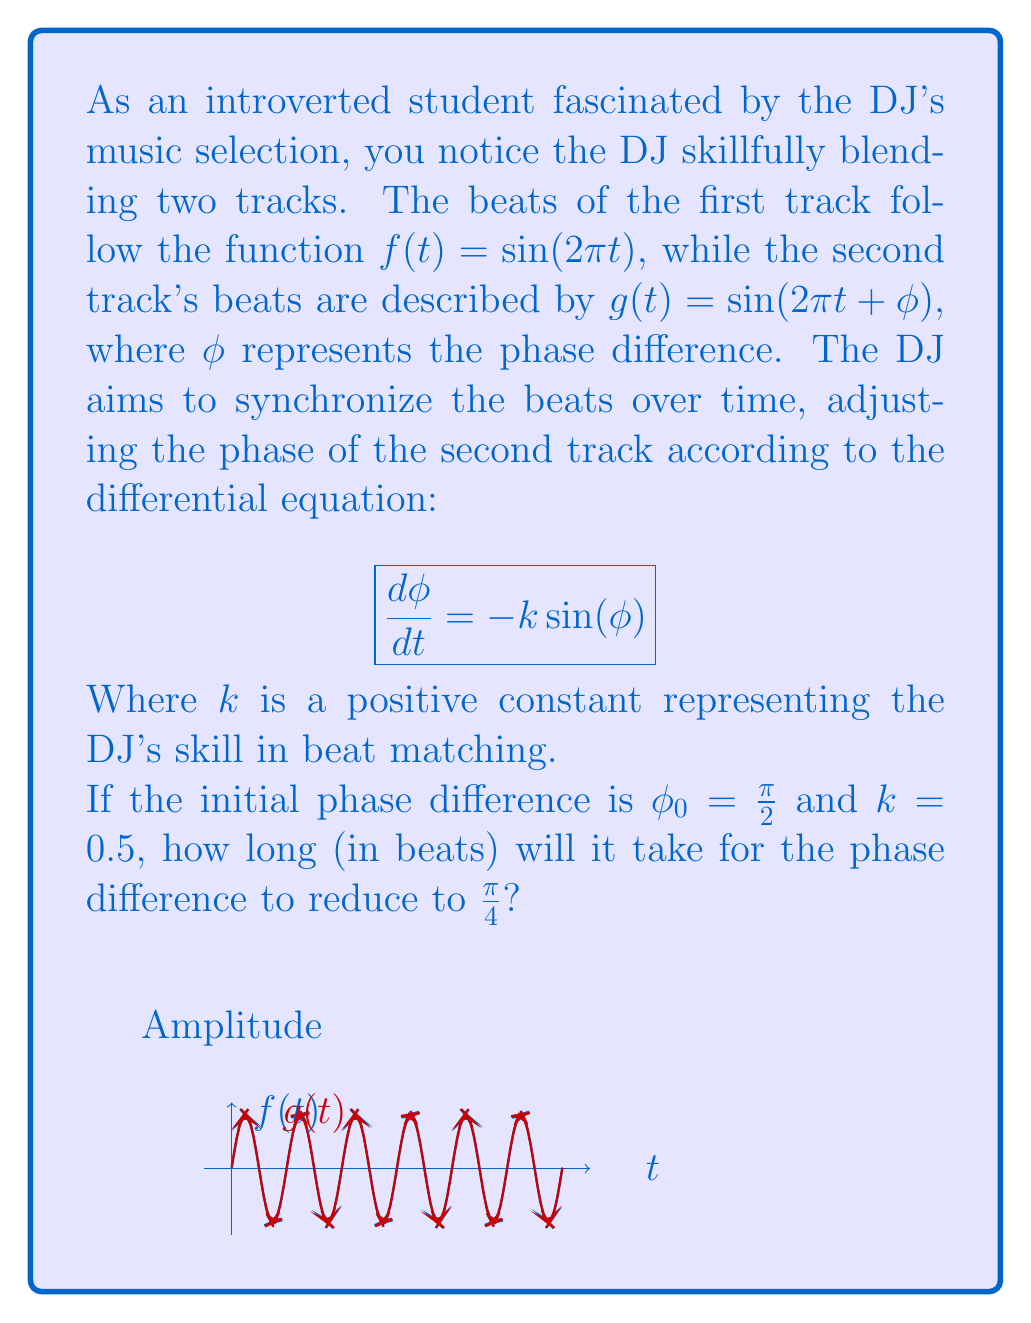What is the answer to this math problem? To solve this problem, we'll follow these steps:

1) The differential equation governing the phase difference is:

   $$\frac{d\phi}{dt} = -k\sin(\phi)$$

2) We can separate variables:

   $$\frac{d\phi}{\sin(\phi)} = -k dt$$

3) Integrating both sides:

   $$\int_{\phi_0}^{\phi} \frac{d\phi}{\sin(\phi)} = -k \int_0^t dt$$

4) The left-hand side integrates to $\ln|\tan(\frac{\phi}{2})|$, so we have:

   $$\ln|\tan(\frac{\phi}{2})| - \ln|\tan(\frac{\phi_0}{2})| = -kt$$

5) Simplifying:

   $$\ln\left|\frac{\tan(\frac{\phi}{2})}{\tan(\frac{\phi_0}{2})}\right| = -kt$$

6) Exponentiating both sides:

   $$\frac{\tan(\frac{\phi}{2})}{\tan(\frac{\phi_0}{2})} = e^{-kt}$$

7) Solving for $t$:

   $$t = -\frac{1}{k}\ln\left(\frac{\tan(\frac{\phi}{2})}{\tan(\frac{\phi_0}{2})}\right)$$

8) Now, we can plug in our values:
   $\phi_0 = \frac{\pi}{2}$, $\phi = \frac{\pi}{4}$, and $k = 0.5$

   $$t = -\frac{1}{0.5}\ln\left(\frac{\tan(\frac{\pi}{8})}{\tan(\frac{\pi}{4})}\right)$$

9) Simplify:
   $$t = -2\ln\left(\frac{\tan(\frac{\pi}{8})}{1}\right) = -2\ln(\tan(\frac{\pi}{8})) \approx 2.78$$

Therefore, it will take approximately 2.78 beats for the phase difference to reduce from $\frac{\pi}{2}$ to $\frac{\pi}{4}$.
Answer: 2.78 beats 